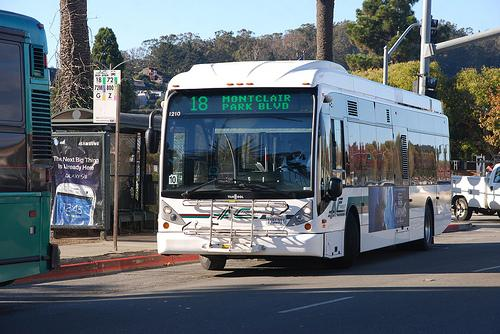List two types of vehicles present in the picture apart from the main subject. A green bus and a white pickup truck turning the corner are also present. What is the primary vehicle in the image and what is it doing? The primary vehicle is a white public transit bus pulling away from the curb. Mention any visible mode of transportation on the bus, and the current state of it. An empty bike rack is present on the front of the bus and it's not being used. Describe the bus stop. black covered bus stop with tinted plexiglass windows X:52 Y:105 Width:108 Height:108 Analyze the interactions between objects in the image. Bus pulling away from the curb, bike rack on the bus, the truck behind the bus Identify the emotions conveyed by the image. Neutral List the types of vehicles in the image. White public transit bus, green bus, white truck Describe the white pickup truck in the image. White pickup truck: X:445 Y:159 Width:53 Height:53 Is there a person standing under the silver metal street light? This instruction is misleading because there is no information about a person standing under the street light. The image only provides the position and size of the street light. Can you see any tree trunks in the image? Yes, trunk of tree with no limbs visible: X:53 Y:0 Width:46 Height:46 Is there a bike rack on the front of the bus? Yes Point out objects mentioned in the following expression: "Green led screen on the bus and street light behind the bus." green led screen: X:185 Y:86 Width:107 Height:107; street light: X:380 Y:12 Width:55 Height:55 How many windows are on the white bus? Three Spot any anomalies in the image. None Assess the quality of the image. Good Locate the windshield of the white bus. windshield on white bus: X:164 Y:118 Width:149 Height:149 Describe the street light in the image. Silver metal street light: X:377 Y:14 Width:59 Height:59 Extract any text visible in the image. The 18 on the front of the bus Find the digital sign with the bus destination. Digital sign with bus destination: X:165 Y:83 Width:156 Height:156 Is the white pickup truck parked next to the bus? This instruction is misleading because the white pickup truck is actually turning the corner, not parked next to the bus. Does the green LED screen on the bus display the number 25? This instruction is misleading because there is no information about what number is displayed on the green LED screen. The image only provides the position and size of the screen. Identify the color of the bus. White Locate the shadow on the ground. Shadow on the ground X:150 Y:292 Width:94 Height:94 Is the bike rack on the bus empty or occupied? Empty Is the bus stop sign on the sidewalk made of wood? The instruction is misleading because the bus stop sign is actually on a metal pole, not made of wood. Do the windows on the white bus have curtains? This instruction is misleading because there is no information about curtains on the windows. The image only provides the position and size of the windows. Are there two bikes attached to the bike rack on the front of the bus? This instruction is misleading because there is no information about the number of bikes attached to the bike rack. The image only provides the position and size of the bike rack. Find the position of the back end of the green bus. Back end of green bus X:2 Y:2 Width:69 Height:69 